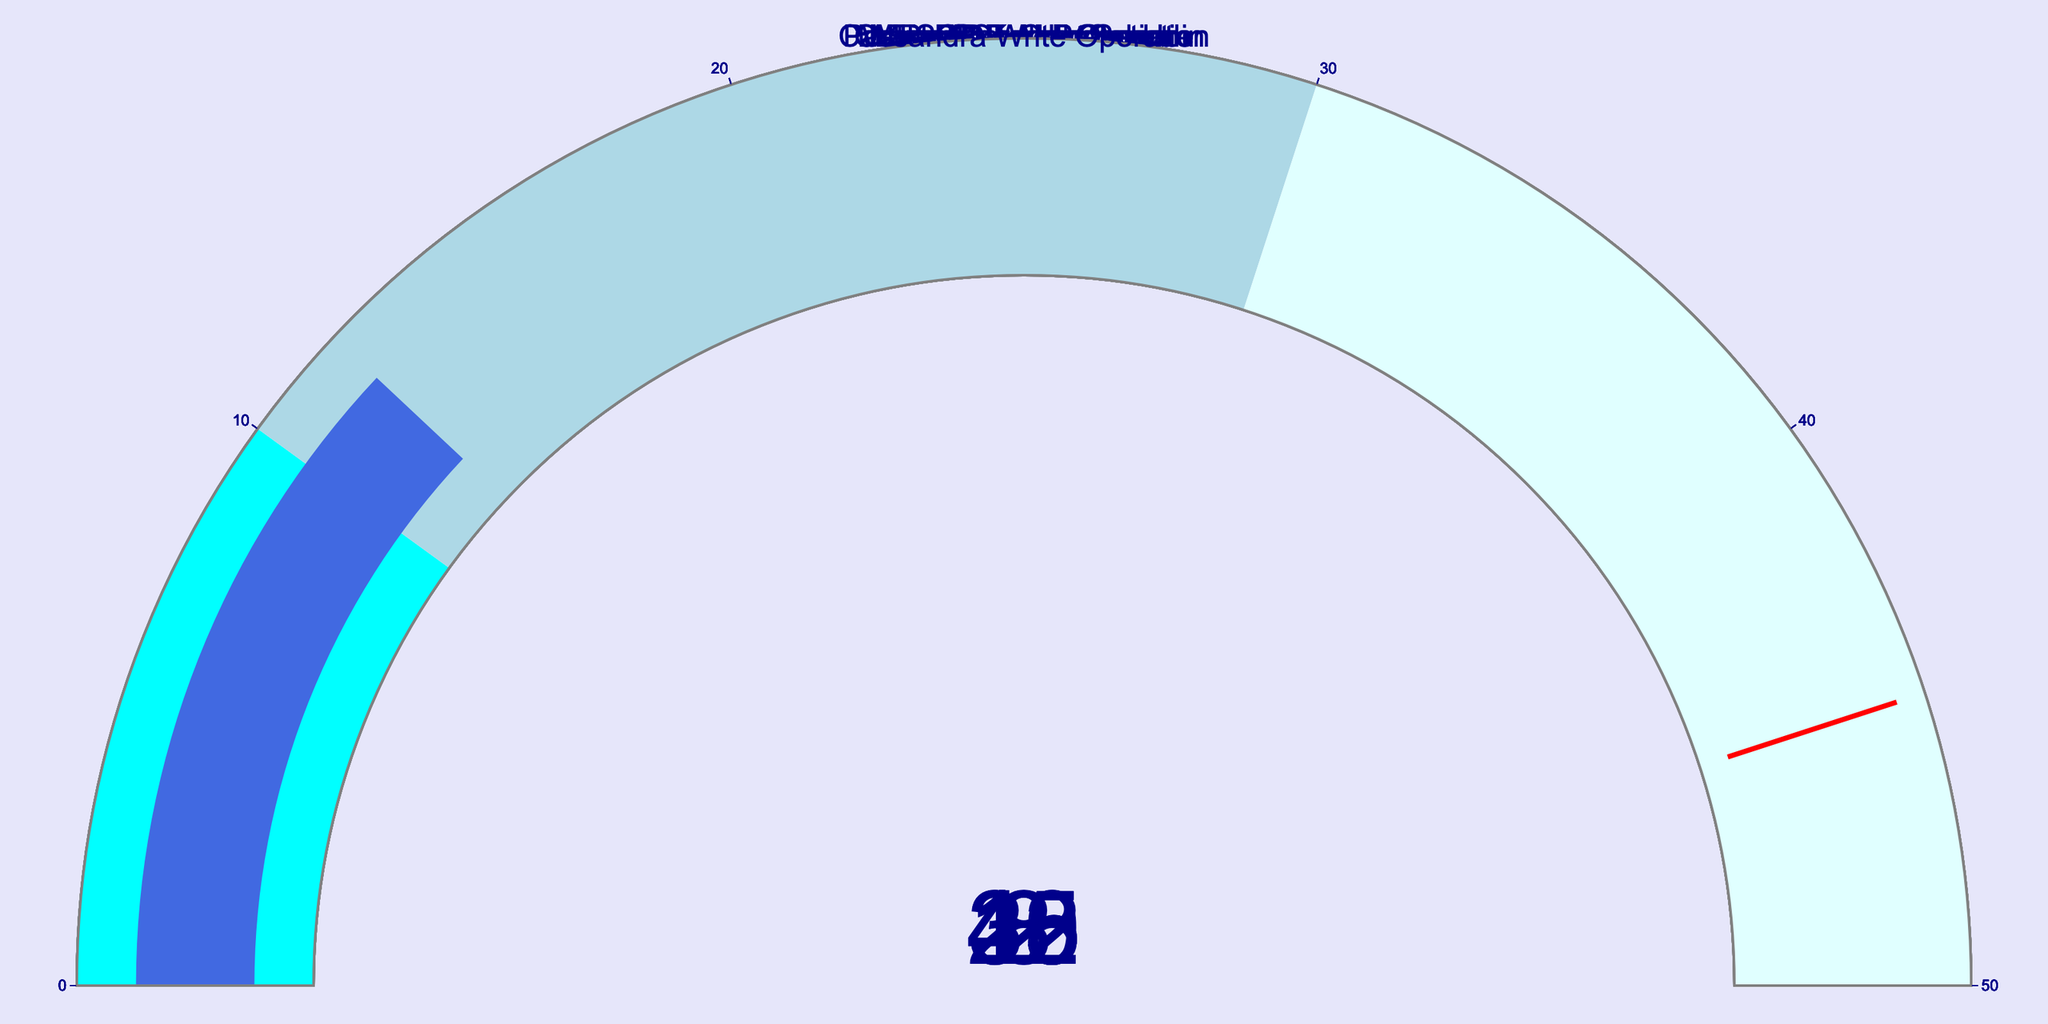What is the query response time for MongoDB Aggregation? The gauge specifically indicates the response time for MongoDB Aggregation is at 30 milliseconds.
Answer: 30 ms Which database shows the fastest query response? The smallest value across all gauges indicates the fastest response time. Here, Redis Key Lookup shows the fastest query response at 2 milliseconds.
Answer: Redis Key Lookup How many databases have a query response time greater than 30 milliseconds? By checking each gauge's value, MySQL Innodb Select (15 ms), MongoDB Aggregation (30 ms), Oracle Stored Procedure (25 ms), MariaDB Fulltext Search (38 ms), Elasticsearch Query (8 ms), and Cassandra Write Operation (12 ms) are less than or equal to 30 ms. MySQL Innodb Select (15 ms)< MongoDB Aggregation (30 ms), and PostgreSQL Complex Join (45 ms) are not. Therefore, PostgreSQL Complex Join has the highest.
Answer: 2 How does the response time of Elasticsearch Query compare to Cassandra Write Operation? Elasticsearch Query has a gauge value of 8 ms and Cassandra Write Operation has 12 ms. Hence, Elasticsearch Query is faster by 4 milliseconds.
Answer: Elasticsearch Query is faster by 4 ms What is the average query response time of all the databases? Add all query response times: 15 + 45 + 30 + 2 + 25 + 38 + 8 + 12 = 175 ms. Divide by the total number of databases, 8: 175 / 8 = 21.875 ms.
Answer: 21.875 ms Which database has the second fastest query response time? Sorting the response times: Redis Key Lookup (2 ms) < Elasticsearch Query (8 ms) < Cassandra Write Operation (12 ms) < MySQL Innodb Select (15 ms) < Oracle Stored Procedure (25 ms) < MongoDB Aggregation (30 ms) < MariaDB Fulltext Search (38 ms) < PostgreSQL Complex Join (45 ms). The second fastest is Elasticsearch Query.
Answer: Elasticsearch Query 